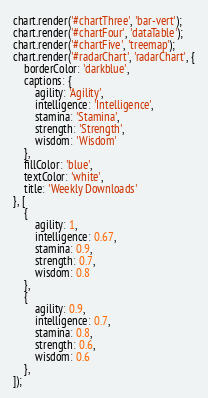Convert code to text. <code><loc_0><loc_0><loc_500><loc_500><_JavaScript_>chart.render('#chartThree', 'bar-vert');
chart.render('#chartFour', 'dataTable');
chart.render('#chartFive', 'treemap');
chart.render('#radarChart', 'radarChart', {
    borderColor: 'darkblue',
    captions: {
        agility: 'Agility',
        intelligence: 'Intelligence',
        stamina: 'Stamina',
        strength: 'Strength',
        wisdom: 'Wisdom'
    },
    fillColor: 'blue',
    textColor: 'white',
    title: 'Weekly Downloads'
}, [
    {
        agility: 1,
        intelligence: 0.67,
        stamina: 0.9,
        strength: 0.7,
        wisdom: 0.8
    },
    {
        agility: 0.9,
        intelligence: 0.7,
        stamina: 0.8,
        strength: 0.6,
        wisdom: 0.6
    },
]);</code> 